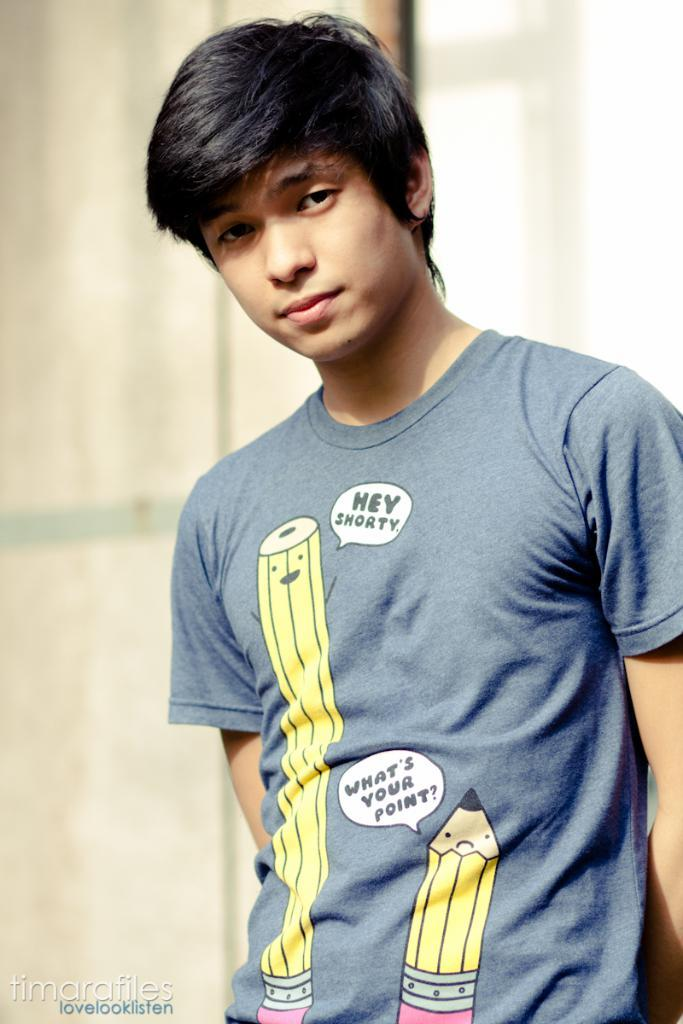<image>
Share a concise interpretation of the image provided. a boy with a tshirt with a pencil saying hey shorty 